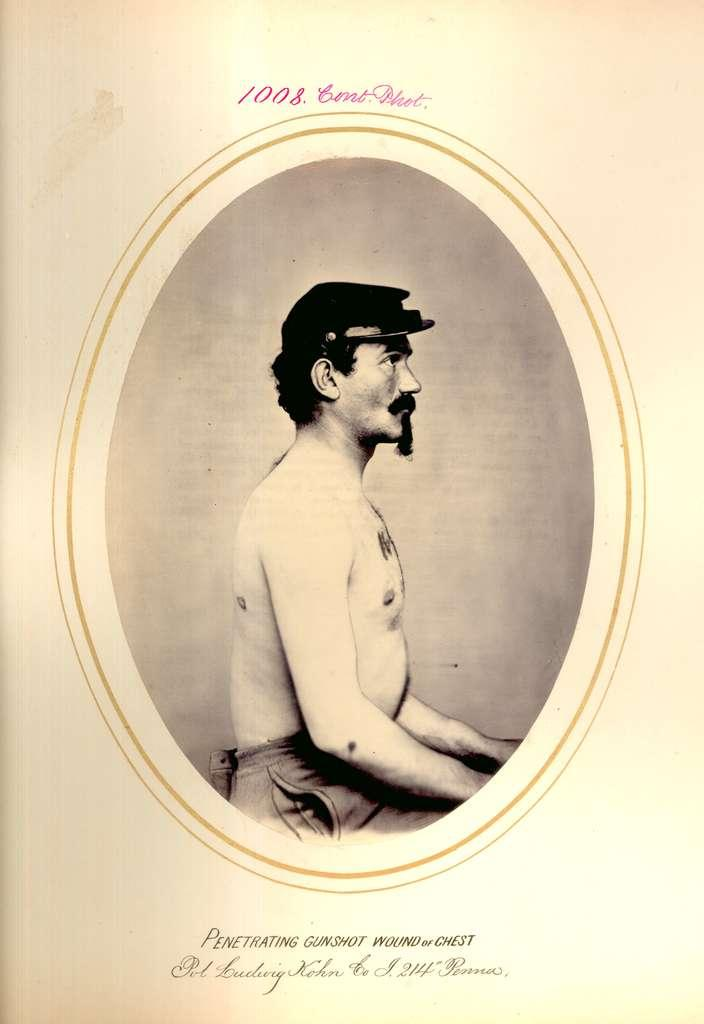What is the main subject of the image? There is a person in the image. In which direction is the person facing? The person is facing towards the right. What type of clothing is the person wearing on their head? The person is wearing a cap. What type of clothing is the person wearing on their lower body? The person is wearing pants. What type of pies is the secretary holding in the image? There is no secretary or pies present in the image; it features a person wearing a cap and pants. 